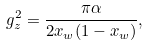Convert formula to latex. <formula><loc_0><loc_0><loc_500><loc_500>g _ { z } ^ { 2 } = \frac { \pi \alpha } { 2 x _ { w } ( 1 - x _ { w } ) } ,</formula> 